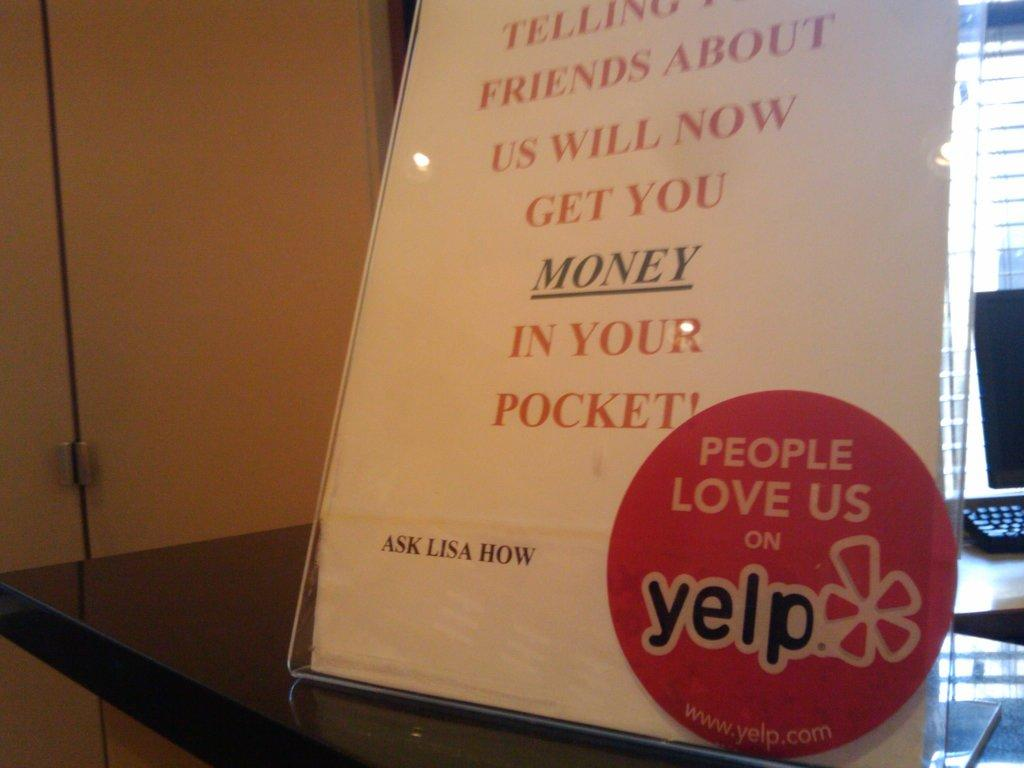<image>
Share a concise interpretation of the image provided. A sign asking customers to ask lisa how to get money 